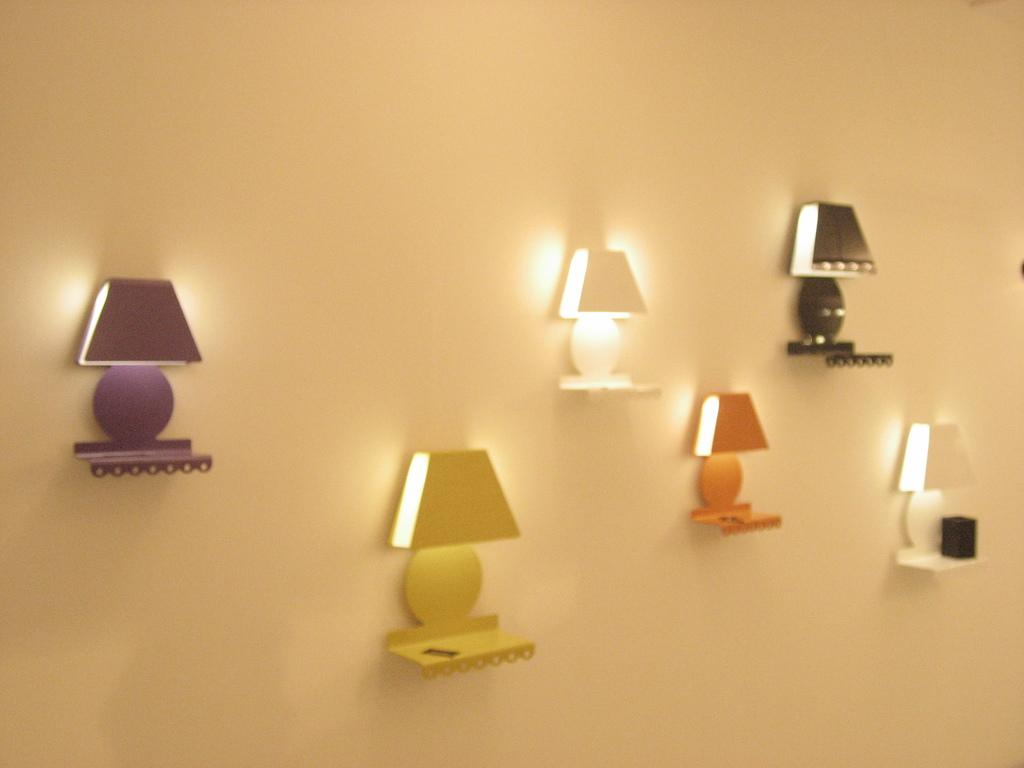What objects are in the foreground of the image? There are lamp stands in the foreground of the image. Where are the lamp stands positioned? The lamp stands are on the wall. What type of scissors can be seen being used by the passenger on the train in the image? There is no train, passenger, or scissors present in the image; it features lamp stands on the wall. 